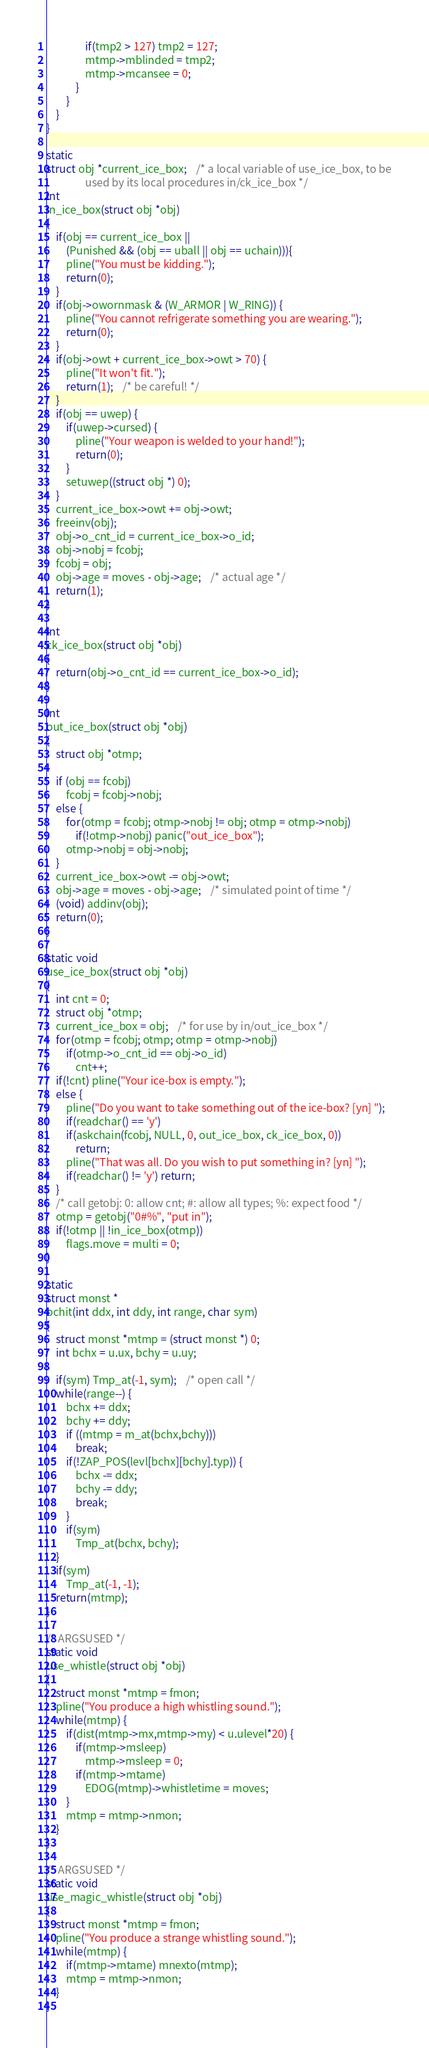Convert code to text. <code><loc_0><loc_0><loc_500><loc_500><_C_>				if(tmp2 > 127) tmp2 = 127;
				mtmp->mblinded = tmp2;
				mtmp->mcansee = 0;
			}
		}
	}
}

static
struct obj *current_ice_box;	/* a local variable of use_ice_box, to be
				used by its local procedures in/ck_ice_box */
int
in_ice_box(struct obj *obj)
{
	if(obj == current_ice_box ||
		(Punished && (obj == uball || obj == uchain))){
		pline("You must be kidding.");
		return(0);
	}
	if(obj->owornmask & (W_ARMOR | W_RING)) {
		pline("You cannot refrigerate something you are wearing.");
		return(0);
	}
	if(obj->owt + current_ice_box->owt > 70) {
		pline("It won't fit.");
		return(1);	/* be careful! */
	}
	if(obj == uwep) {
		if(uwep->cursed) {
			pline("Your weapon is welded to your hand!");
			return(0);
		}
		setuwep((struct obj *) 0);
	}
	current_ice_box->owt += obj->owt;
	freeinv(obj);
	obj->o_cnt_id = current_ice_box->o_id;
	obj->nobj = fcobj;
	fcobj = obj;
	obj->age = moves - obj->age;	/* actual age */
	return(1);
}

int
ck_ice_box(struct obj *obj)
{
	return(obj->o_cnt_id == current_ice_box->o_id);
}

int
out_ice_box(struct obj *obj)
{
	struct obj *otmp;

	if (obj == fcobj)
		fcobj = fcobj->nobj;
	else {
		for(otmp = fcobj; otmp->nobj != obj; otmp = otmp->nobj)
			if(!otmp->nobj) panic("out_ice_box");
		otmp->nobj = obj->nobj;
	}
	current_ice_box->owt -= obj->owt;
	obj->age = moves - obj->age;	/* simulated point of time */
	(void) addinv(obj);
	return(0);
}

static void
use_ice_box(struct obj *obj)
{
	int cnt = 0;
	struct obj *otmp;
	current_ice_box = obj;	/* for use by in/out_ice_box */
	for(otmp = fcobj; otmp; otmp = otmp->nobj)
		if(otmp->o_cnt_id == obj->o_id)
			cnt++;
	if(!cnt) pline("Your ice-box is empty.");
	else {
	    pline("Do you want to take something out of the ice-box? [yn] ");
	    if(readchar() == 'y')
		if(askchain(fcobj, NULL, 0, out_ice_box, ck_ice_box, 0))
		    return;
		pline("That was all. Do you wish to put something in? [yn] ");
		if(readchar() != 'y') return;
	}
	/* call getobj: 0: allow cnt; #: allow all types; %: expect food */
	otmp = getobj("0#%", "put in");
	if(!otmp || !in_ice_box(otmp))
		flags.move = multi = 0;
}

static
struct monst *
bchit(int ddx, int ddy, int range, char sym)
{
	struct monst *mtmp = (struct monst *) 0;
	int bchx = u.ux, bchy = u.uy;

	if(sym) Tmp_at(-1, sym);	/* open call */
	while(range--) {
		bchx += ddx;
		bchy += ddy;
		if ((mtmp = m_at(bchx,bchy)))
			break;
		if(!ZAP_POS(levl[bchx][bchy].typ)) {
			bchx -= ddx;
			bchy -= ddy;
			break;
		}
		if(sym)
			Tmp_at(bchx, bchy);
	}
	if(sym)
		Tmp_at(-1, -1);
	return(mtmp);
}

/* ARGSUSED */
static void
use_whistle(struct obj *obj)
{
	struct monst *mtmp = fmon;
	pline("You produce a high whistling sound.");
	while(mtmp) {
		if(dist(mtmp->mx,mtmp->my) < u.ulevel*20) {
			if(mtmp->msleep)
				mtmp->msleep = 0;
			if(mtmp->mtame)
				EDOG(mtmp)->whistletime = moves;
		}
		mtmp = mtmp->nmon;
	}
}

/* ARGSUSED */
static void
use_magic_whistle(struct obj *obj)
{
	struct monst *mtmp = fmon;
	pline("You produce a strange whistling sound.");
	while(mtmp) {
		if(mtmp->mtame) mnexto(mtmp);
		mtmp = mtmp->nmon;
	}
}
</code> 